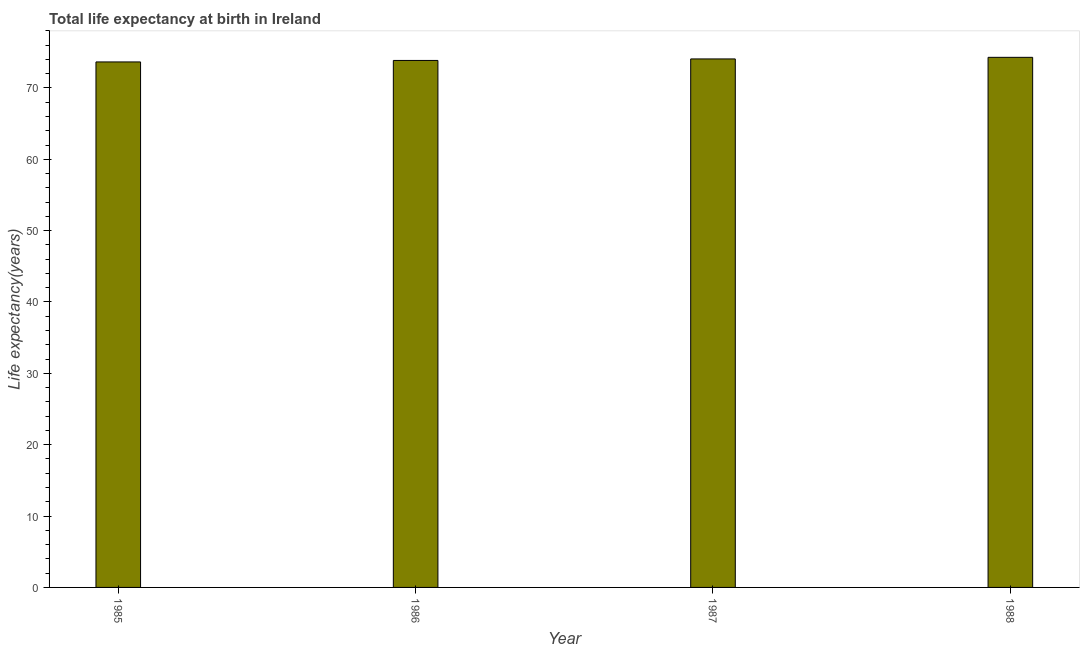Does the graph contain any zero values?
Provide a succinct answer. No. Does the graph contain grids?
Your answer should be compact. No. What is the title of the graph?
Offer a terse response. Total life expectancy at birth in Ireland. What is the label or title of the Y-axis?
Your response must be concise. Life expectancy(years). What is the life expectancy at birth in 1988?
Give a very brief answer. 74.29. Across all years, what is the maximum life expectancy at birth?
Offer a very short reply. 74.29. Across all years, what is the minimum life expectancy at birth?
Offer a terse response. 73.64. In which year was the life expectancy at birth minimum?
Ensure brevity in your answer.  1985. What is the sum of the life expectancy at birth?
Offer a terse response. 295.84. What is the difference between the life expectancy at birth in 1985 and 1987?
Your response must be concise. -0.42. What is the average life expectancy at birth per year?
Offer a terse response. 73.96. What is the median life expectancy at birth?
Give a very brief answer. 73.96. Is the life expectancy at birth in 1985 less than that in 1988?
Give a very brief answer. Yes. Is the difference between the life expectancy at birth in 1986 and 1987 greater than the difference between any two years?
Your answer should be very brief. No. What is the difference between the highest and the second highest life expectancy at birth?
Your answer should be very brief. 0.22. Is the sum of the life expectancy at birth in 1985 and 1986 greater than the maximum life expectancy at birth across all years?
Offer a terse response. Yes. What is the difference between the highest and the lowest life expectancy at birth?
Your response must be concise. 0.65. In how many years, is the life expectancy at birth greater than the average life expectancy at birth taken over all years?
Provide a succinct answer. 2. How many bars are there?
Your answer should be compact. 4. Are all the bars in the graph horizontal?
Your answer should be compact. No. What is the difference between two consecutive major ticks on the Y-axis?
Provide a short and direct response. 10. What is the Life expectancy(years) in 1985?
Provide a short and direct response. 73.64. What is the Life expectancy(years) in 1986?
Give a very brief answer. 73.85. What is the Life expectancy(years) in 1987?
Ensure brevity in your answer.  74.06. What is the Life expectancy(years) of 1988?
Your response must be concise. 74.29. What is the difference between the Life expectancy(years) in 1985 and 1986?
Provide a succinct answer. -0.21. What is the difference between the Life expectancy(years) in 1985 and 1987?
Your answer should be very brief. -0.42. What is the difference between the Life expectancy(years) in 1985 and 1988?
Keep it short and to the point. -0.65. What is the difference between the Life expectancy(years) in 1986 and 1987?
Your answer should be compact. -0.21. What is the difference between the Life expectancy(years) in 1986 and 1988?
Ensure brevity in your answer.  -0.44. What is the difference between the Life expectancy(years) in 1987 and 1988?
Ensure brevity in your answer.  -0.22. What is the ratio of the Life expectancy(years) in 1985 to that in 1986?
Provide a succinct answer. 1. What is the ratio of the Life expectancy(years) in 1985 to that in 1988?
Keep it short and to the point. 0.99. What is the ratio of the Life expectancy(years) in 1986 to that in 1988?
Keep it short and to the point. 0.99. 